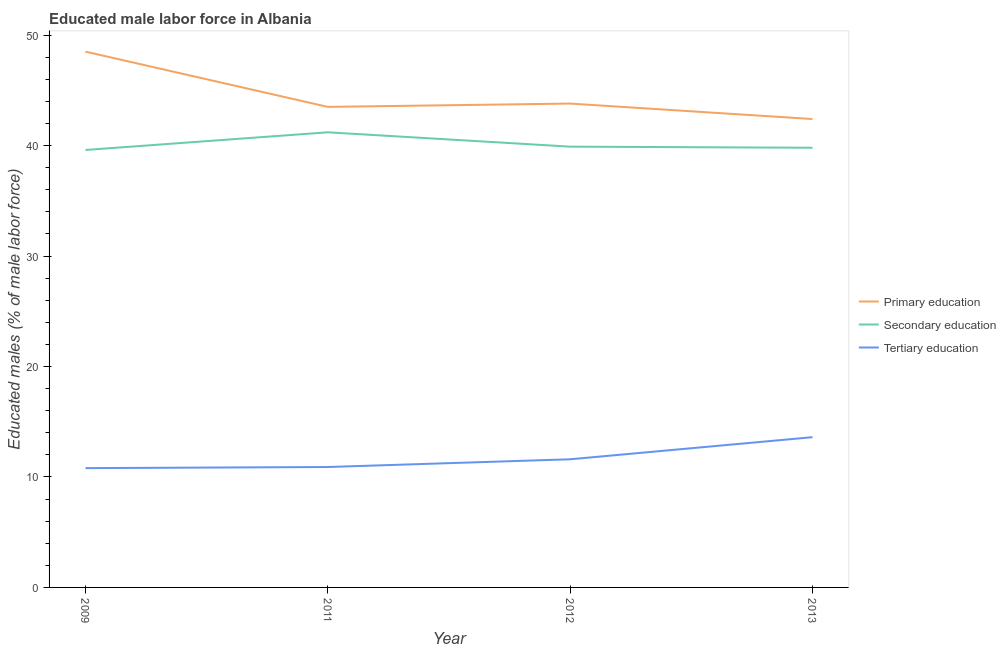How many different coloured lines are there?
Offer a very short reply. 3. Does the line corresponding to percentage of male labor force who received tertiary education intersect with the line corresponding to percentage of male labor force who received primary education?
Make the answer very short. No. What is the percentage of male labor force who received secondary education in 2011?
Offer a very short reply. 41.2. Across all years, what is the maximum percentage of male labor force who received primary education?
Your response must be concise. 48.5. Across all years, what is the minimum percentage of male labor force who received primary education?
Your answer should be compact. 42.4. What is the total percentage of male labor force who received secondary education in the graph?
Provide a short and direct response. 160.5. What is the difference between the percentage of male labor force who received secondary education in 2011 and that in 2013?
Offer a very short reply. 1.4. What is the difference between the percentage of male labor force who received tertiary education in 2011 and the percentage of male labor force who received primary education in 2009?
Offer a terse response. -37.6. What is the average percentage of male labor force who received primary education per year?
Make the answer very short. 44.55. In the year 2013, what is the difference between the percentage of male labor force who received secondary education and percentage of male labor force who received primary education?
Ensure brevity in your answer.  -2.6. What is the ratio of the percentage of male labor force who received primary education in 2009 to that in 2013?
Ensure brevity in your answer.  1.14. Is the percentage of male labor force who received primary education in 2009 less than that in 2011?
Your response must be concise. No. Is the difference between the percentage of male labor force who received secondary education in 2009 and 2012 greater than the difference between the percentage of male labor force who received primary education in 2009 and 2012?
Give a very brief answer. No. What is the difference between the highest and the second highest percentage of male labor force who received secondary education?
Ensure brevity in your answer.  1.3. What is the difference between the highest and the lowest percentage of male labor force who received primary education?
Provide a short and direct response. 6.1. In how many years, is the percentage of male labor force who received tertiary education greater than the average percentage of male labor force who received tertiary education taken over all years?
Make the answer very short. 1. Is the sum of the percentage of male labor force who received primary education in 2009 and 2013 greater than the maximum percentage of male labor force who received secondary education across all years?
Your response must be concise. Yes. Is it the case that in every year, the sum of the percentage of male labor force who received primary education and percentage of male labor force who received secondary education is greater than the percentage of male labor force who received tertiary education?
Provide a short and direct response. Yes. Is the percentage of male labor force who received secondary education strictly greater than the percentage of male labor force who received tertiary education over the years?
Give a very brief answer. Yes. How many lines are there?
Your response must be concise. 3. How many years are there in the graph?
Offer a terse response. 4. What is the difference between two consecutive major ticks on the Y-axis?
Offer a terse response. 10. Does the graph contain any zero values?
Ensure brevity in your answer.  No. Where does the legend appear in the graph?
Keep it short and to the point. Center right. What is the title of the graph?
Provide a succinct answer. Educated male labor force in Albania. Does "New Zealand" appear as one of the legend labels in the graph?
Your response must be concise. No. What is the label or title of the Y-axis?
Provide a succinct answer. Educated males (% of male labor force). What is the Educated males (% of male labor force) of Primary education in 2009?
Give a very brief answer. 48.5. What is the Educated males (% of male labor force) of Secondary education in 2009?
Keep it short and to the point. 39.6. What is the Educated males (% of male labor force) of Tertiary education in 2009?
Make the answer very short. 10.8. What is the Educated males (% of male labor force) in Primary education in 2011?
Your answer should be compact. 43.5. What is the Educated males (% of male labor force) in Secondary education in 2011?
Provide a succinct answer. 41.2. What is the Educated males (% of male labor force) of Tertiary education in 2011?
Make the answer very short. 10.9. What is the Educated males (% of male labor force) of Primary education in 2012?
Your response must be concise. 43.8. What is the Educated males (% of male labor force) in Secondary education in 2012?
Make the answer very short. 39.9. What is the Educated males (% of male labor force) of Tertiary education in 2012?
Your response must be concise. 11.6. What is the Educated males (% of male labor force) of Primary education in 2013?
Your answer should be very brief. 42.4. What is the Educated males (% of male labor force) of Secondary education in 2013?
Offer a very short reply. 39.8. What is the Educated males (% of male labor force) of Tertiary education in 2013?
Your answer should be compact. 13.6. Across all years, what is the maximum Educated males (% of male labor force) in Primary education?
Offer a terse response. 48.5. Across all years, what is the maximum Educated males (% of male labor force) in Secondary education?
Offer a very short reply. 41.2. Across all years, what is the maximum Educated males (% of male labor force) of Tertiary education?
Your response must be concise. 13.6. Across all years, what is the minimum Educated males (% of male labor force) in Primary education?
Your answer should be compact. 42.4. Across all years, what is the minimum Educated males (% of male labor force) of Secondary education?
Your answer should be very brief. 39.6. Across all years, what is the minimum Educated males (% of male labor force) of Tertiary education?
Keep it short and to the point. 10.8. What is the total Educated males (% of male labor force) of Primary education in the graph?
Give a very brief answer. 178.2. What is the total Educated males (% of male labor force) in Secondary education in the graph?
Give a very brief answer. 160.5. What is the total Educated males (% of male labor force) in Tertiary education in the graph?
Your answer should be very brief. 46.9. What is the difference between the Educated males (% of male labor force) in Primary education in 2009 and that in 2011?
Give a very brief answer. 5. What is the difference between the Educated males (% of male labor force) in Secondary education in 2009 and that in 2011?
Keep it short and to the point. -1.6. What is the difference between the Educated males (% of male labor force) of Primary education in 2009 and that in 2012?
Ensure brevity in your answer.  4.7. What is the difference between the Educated males (% of male labor force) in Primary education in 2009 and that in 2013?
Your answer should be very brief. 6.1. What is the difference between the Educated males (% of male labor force) of Tertiary education in 2011 and that in 2012?
Your response must be concise. -0.7. What is the difference between the Educated males (% of male labor force) in Primary education in 2011 and that in 2013?
Provide a succinct answer. 1.1. What is the difference between the Educated males (% of male labor force) of Secondary education in 2011 and that in 2013?
Your answer should be compact. 1.4. What is the difference between the Educated males (% of male labor force) in Secondary education in 2012 and that in 2013?
Your response must be concise. 0.1. What is the difference between the Educated males (% of male labor force) of Primary education in 2009 and the Educated males (% of male labor force) of Secondary education in 2011?
Ensure brevity in your answer.  7.3. What is the difference between the Educated males (% of male labor force) of Primary education in 2009 and the Educated males (% of male labor force) of Tertiary education in 2011?
Your answer should be very brief. 37.6. What is the difference between the Educated males (% of male labor force) of Secondary education in 2009 and the Educated males (% of male labor force) of Tertiary education in 2011?
Provide a short and direct response. 28.7. What is the difference between the Educated males (% of male labor force) of Primary education in 2009 and the Educated males (% of male labor force) of Secondary education in 2012?
Your response must be concise. 8.6. What is the difference between the Educated males (% of male labor force) in Primary education in 2009 and the Educated males (% of male labor force) in Tertiary education in 2012?
Make the answer very short. 36.9. What is the difference between the Educated males (% of male labor force) in Secondary education in 2009 and the Educated males (% of male labor force) in Tertiary education in 2012?
Provide a succinct answer. 28. What is the difference between the Educated males (% of male labor force) in Primary education in 2009 and the Educated males (% of male labor force) in Secondary education in 2013?
Make the answer very short. 8.7. What is the difference between the Educated males (% of male labor force) of Primary education in 2009 and the Educated males (% of male labor force) of Tertiary education in 2013?
Offer a terse response. 34.9. What is the difference between the Educated males (% of male labor force) in Secondary education in 2009 and the Educated males (% of male labor force) in Tertiary education in 2013?
Provide a succinct answer. 26. What is the difference between the Educated males (% of male labor force) in Primary education in 2011 and the Educated males (% of male labor force) in Tertiary education in 2012?
Provide a succinct answer. 31.9. What is the difference between the Educated males (% of male labor force) of Secondary education in 2011 and the Educated males (% of male labor force) of Tertiary education in 2012?
Provide a short and direct response. 29.6. What is the difference between the Educated males (% of male labor force) of Primary education in 2011 and the Educated males (% of male labor force) of Tertiary education in 2013?
Your response must be concise. 29.9. What is the difference between the Educated males (% of male labor force) in Secondary education in 2011 and the Educated males (% of male labor force) in Tertiary education in 2013?
Offer a very short reply. 27.6. What is the difference between the Educated males (% of male labor force) in Primary education in 2012 and the Educated males (% of male labor force) in Secondary education in 2013?
Your answer should be compact. 4. What is the difference between the Educated males (% of male labor force) in Primary education in 2012 and the Educated males (% of male labor force) in Tertiary education in 2013?
Offer a terse response. 30.2. What is the difference between the Educated males (% of male labor force) of Secondary education in 2012 and the Educated males (% of male labor force) of Tertiary education in 2013?
Ensure brevity in your answer.  26.3. What is the average Educated males (% of male labor force) of Primary education per year?
Give a very brief answer. 44.55. What is the average Educated males (% of male labor force) in Secondary education per year?
Your answer should be compact. 40.12. What is the average Educated males (% of male labor force) of Tertiary education per year?
Provide a succinct answer. 11.72. In the year 2009, what is the difference between the Educated males (% of male labor force) in Primary education and Educated males (% of male labor force) in Tertiary education?
Provide a succinct answer. 37.7. In the year 2009, what is the difference between the Educated males (% of male labor force) in Secondary education and Educated males (% of male labor force) in Tertiary education?
Ensure brevity in your answer.  28.8. In the year 2011, what is the difference between the Educated males (% of male labor force) of Primary education and Educated males (% of male labor force) of Secondary education?
Make the answer very short. 2.3. In the year 2011, what is the difference between the Educated males (% of male labor force) of Primary education and Educated males (% of male labor force) of Tertiary education?
Offer a very short reply. 32.6. In the year 2011, what is the difference between the Educated males (% of male labor force) in Secondary education and Educated males (% of male labor force) in Tertiary education?
Your answer should be very brief. 30.3. In the year 2012, what is the difference between the Educated males (% of male labor force) in Primary education and Educated males (% of male labor force) in Tertiary education?
Make the answer very short. 32.2. In the year 2012, what is the difference between the Educated males (% of male labor force) in Secondary education and Educated males (% of male labor force) in Tertiary education?
Provide a succinct answer. 28.3. In the year 2013, what is the difference between the Educated males (% of male labor force) of Primary education and Educated males (% of male labor force) of Secondary education?
Ensure brevity in your answer.  2.6. In the year 2013, what is the difference between the Educated males (% of male labor force) in Primary education and Educated males (% of male labor force) in Tertiary education?
Your answer should be very brief. 28.8. In the year 2013, what is the difference between the Educated males (% of male labor force) of Secondary education and Educated males (% of male labor force) of Tertiary education?
Your response must be concise. 26.2. What is the ratio of the Educated males (% of male labor force) in Primary education in 2009 to that in 2011?
Make the answer very short. 1.11. What is the ratio of the Educated males (% of male labor force) in Secondary education in 2009 to that in 2011?
Make the answer very short. 0.96. What is the ratio of the Educated males (% of male labor force) in Tertiary education in 2009 to that in 2011?
Make the answer very short. 0.99. What is the ratio of the Educated males (% of male labor force) of Primary education in 2009 to that in 2012?
Make the answer very short. 1.11. What is the ratio of the Educated males (% of male labor force) in Primary education in 2009 to that in 2013?
Offer a terse response. 1.14. What is the ratio of the Educated males (% of male labor force) in Tertiary education in 2009 to that in 2013?
Make the answer very short. 0.79. What is the ratio of the Educated males (% of male labor force) of Primary education in 2011 to that in 2012?
Offer a very short reply. 0.99. What is the ratio of the Educated males (% of male labor force) of Secondary education in 2011 to that in 2012?
Provide a succinct answer. 1.03. What is the ratio of the Educated males (% of male labor force) of Tertiary education in 2011 to that in 2012?
Your answer should be very brief. 0.94. What is the ratio of the Educated males (% of male labor force) of Primary education in 2011 to that in 2013?
Ensure brevity in your answer.  1.03. What is the ratio of the Educated males (% of male labor force) of Secondary education in 2011 to that in 2013?
Offer a terse response. 1.04. What is the ratio of the Educated males (% of male labor force) of Tertiary education in 2011 to that in 2013?
Provide a short and direct response. 0.8. What is the ratio of the Educated males (% of male labor force) in Primary education in 2012 to that in 2013?
Offer a very short reply. 1.03. What is the ratio of the Educated males (% of male labor force) in Secondary education in 2012 to that in 2013?
Ensure brevity in your answer.  1. What is the ratio of the Educated males (% of male labor force) of Tertiary education in 2012 to that in 2013?
Offer a very short reply. 0.85. What is the difference between the highest and the lowest Educated males (% of male labor force) of Secondary education?
Ensure brevity in your answer.  1.6. 